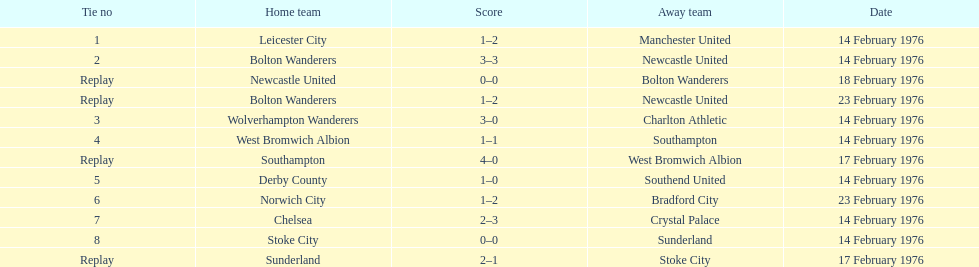What squads are highlighted in the match at the peak of the table? Leicester City, Manchester United. Which one of these two is the host team? Leicester City. 